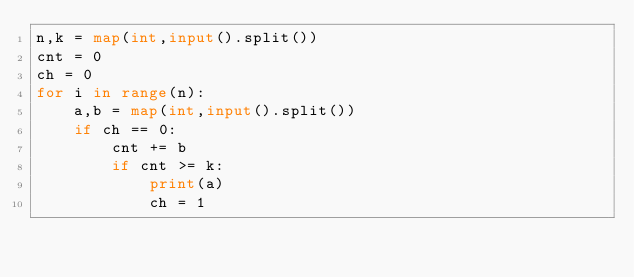Convert code to text. <code><loc_0><loc_0><loc_500><loc_500><_Python_>n,k = map(int,input().split())
cnt = 0
ch = 0
for i in range(n):
    a,b = map(int,input().split())
    if ch == 0:
        cnt += b
        if cnt >= k:
            print(a)
            ch = 1</code> 